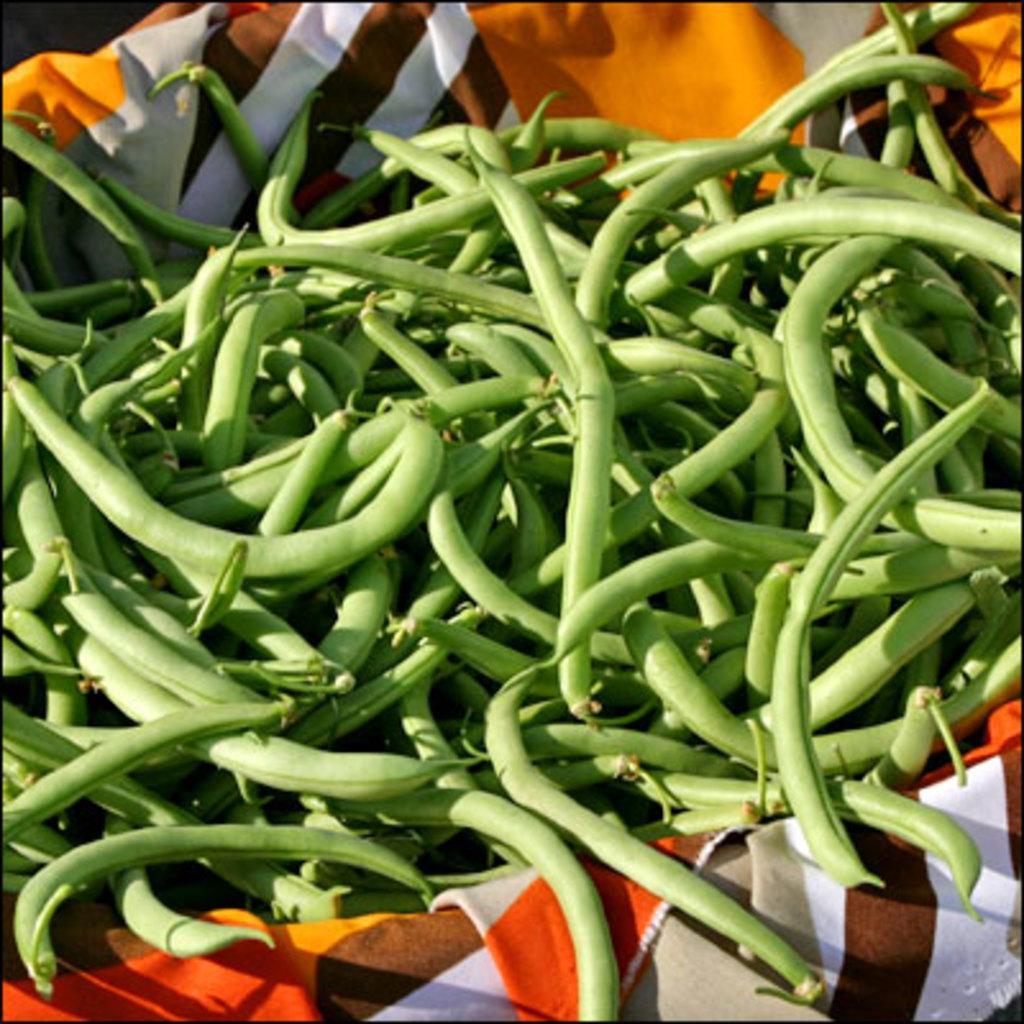Please provide a concise description of this image. In this image there are green beans in a cloth. 